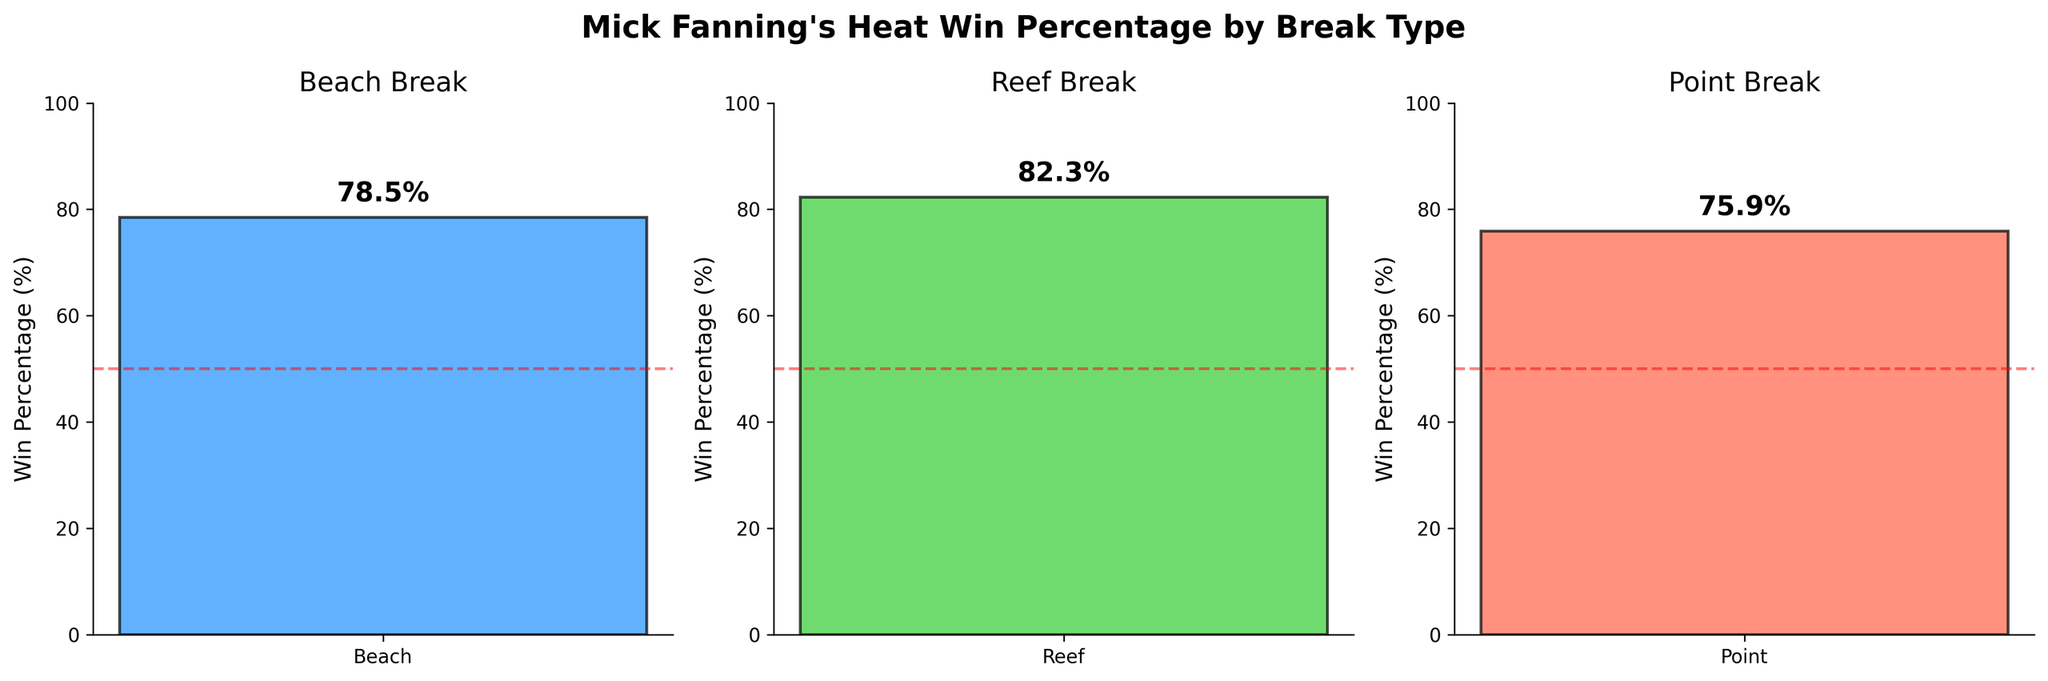What is the difference in win percentage between reef and beach breaks? The reef break win percentage is 82.3%, and the beach break win percentage is 78.5%. The difference is 82.3% - 78.5% = 3.8%.
Answer: 3.8% What is the average win percentage across all break types? The total win percentage is the sum of the win percentages of each break type, (78.5% + 82.3% + 75.9%) = 236.7%. The average is 236.7% / 3 ≈ 78.9%.
Answer: 78.9% Between which two break types is the win percentage difference the smallest? The differences are: reef vs beach = 3.8%, reef vs point = 6.4%, beach vs point = 2.6%. The smallest difference is between beach and point breaks.
Answer: Beach and Point Is there any break type where Fanning’s win percentage exceeds 80%? By looking at the bar heights and their corresponding values, Fanning’s win percentage exceeds 80% in the reef break type (82.3%).
Answer: Yes, Reef How much higher is Fanning's win percentage on reef breaks compared to point breaks? The win percentage for reef breaks is 82.3% and for point breaks is 75.9%. The difference is 82.3% - 75.9% = 6.4%.
Answer: 6.4% What visual elements are used to emphasize the win percentage on each bar? Each bar has a text label indicating the win percentage and a horizontal red dashed line at 50% for reference. Additionally, the bars are color-coded differently for each break type.
Answer: Text labels, red dashed line, different colors How many break types have win percentages less than 80%? By looking at the bar heights, both the beach break (78.5%) and point break (75.9%) have win percentages less than 80%. This accounts for 2 break types.
Answer: Two 